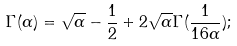<formula> <loc_0><loc_0><loc_500><loc_500>\Gamma ( \alpha ) = \sqrt { \alpha } - \frac { 1 } { 2 } + 2 \sqrt { \alpha } \Gamma ( \frac { 1 } { 1 6 \alpha } ) ;</formula> 